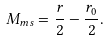<formula> <loc_0><loc_0><loc_500><loc_500>M _ { m s } = \frac { r } { 2 } - \frac { r _ { 0 } } { 2 } .</formula> 